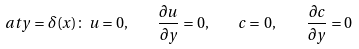<formula> <loc_0><loc_0><loc_500><loc_500>a t y = \delta ( x ) \colon \, u = 0 , \quad \frac { \partial u } { \partial y } = 0 , \quad c = \, 0 , \quad \frac { \partial c } { \partial y } = 0</formula> 